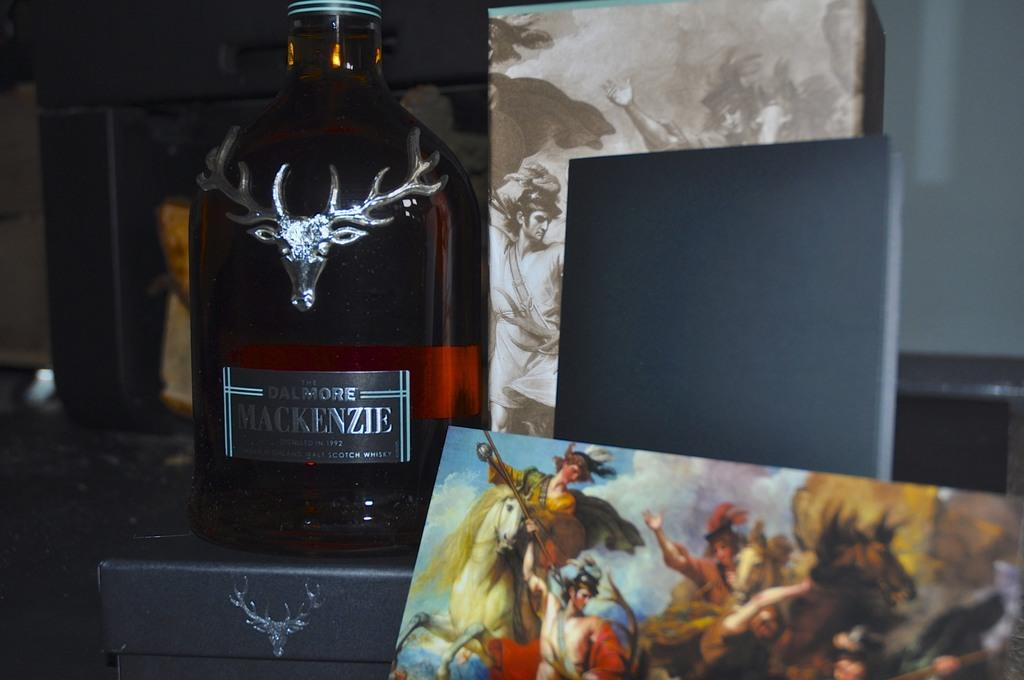<image>
Relay a brief, clear account of the picture shown. A bottle of Dalmore Mackenzie Scotch from 1992 with a silver stag head on the bottle. 